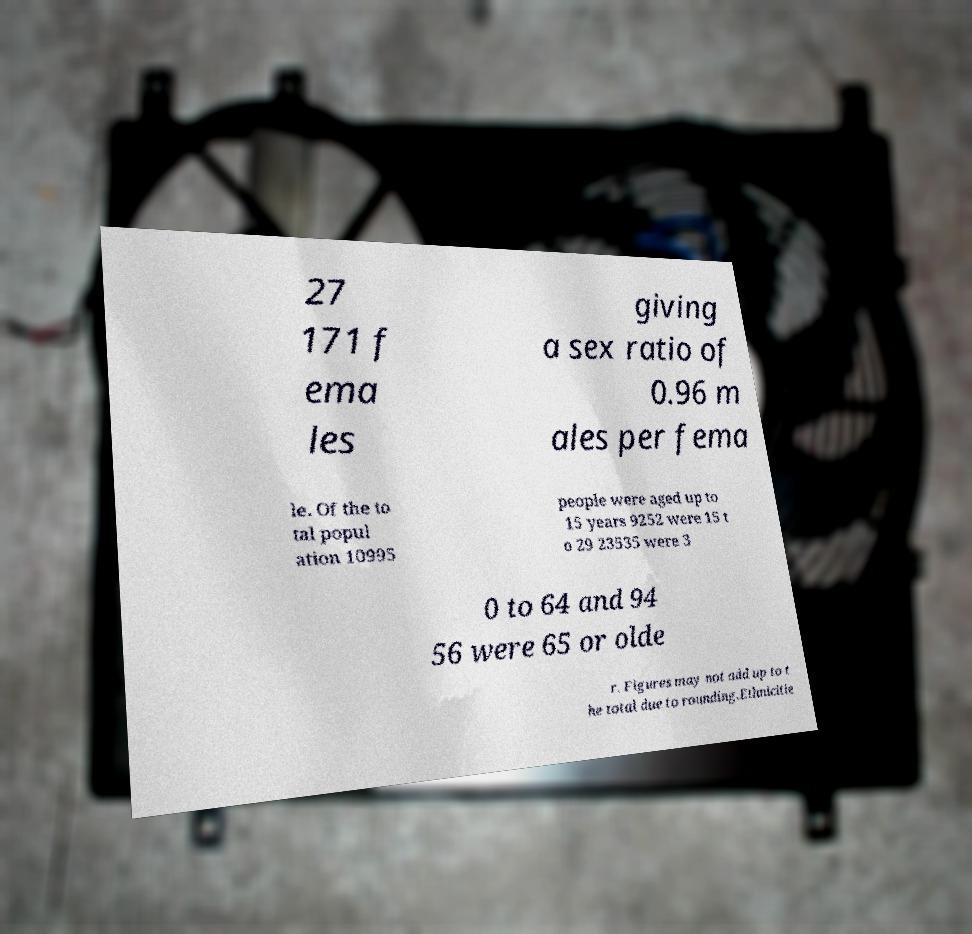Could you extract and type out the text from this image? 27 171 f ema les giving a sex ratio of 0.96 m ales per fema le. Of the to tal popul ation 10995 people were aged up to 15 years 9252 were 15 t o 29 23535 were 3 0 to 64 and 94 56 were 65 or olde r. Figures may not add up to t he total due to rounding.Ethnicitie 